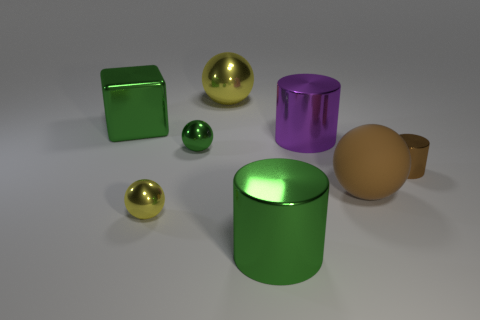Subtract all purple cylinders. How many cylinders are left? 2 Add 1 tiny metal cylinders. How many objects exist? 9 Subtract 1 spheres. How many spheres are left? 3 Subtract all green cylinders. How many yellow balls are left? 2 Subtract all green cylinders. How many cylinders are left? 2 Subtract all cylinders. How many objects are left? 5 Subtract all yellow objects. Subtract all tiny green metal objects. How many objects are left? 5 Add 6 big purple objects. How many big purple objects are left? 7 Add 6 large green things. How many large green things exist? 8 Subtract 0 purple blocks. How many objects are left? 8 